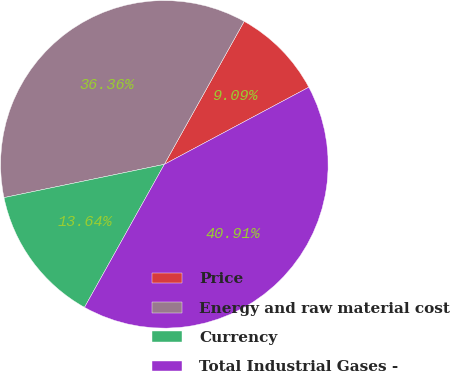Convert chart. <chart><loc_0><loc_0><loc_500><loc_500><pie_chart><fcel>Price<fcel>Energy and raw material cost<fcel>Currency<fcel>Total Industrial Gases -<nl><fcel>9.09%<fcel>36.36%<fcel>13.64%<fcel>40.91%<nl></chart> 